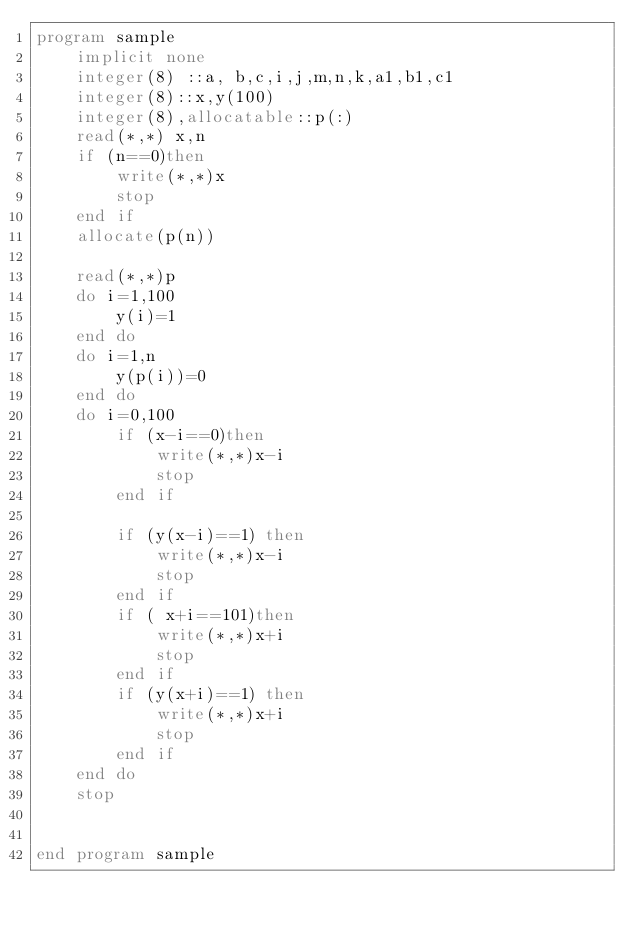<code> <loc_0><loc_0><loc_500><loc_500><_FORTRAN_>program sample
    implicit none
    integer(8) ::a, b,c,i,j,m,n,k,a1,b1,c1
    integer(8)::x,y(100)
    integer(8),allocatable::p(:)
    read(*,*) x,n
    if (n==0)then
        write(*,*)x
        stop
    end if
    allocate(p(n))

    read(*,*)p
    do i=1,100
        y(i)=1
    end do
    do i=1,n
        y(p(i))=0
    end do
    do i=0,100
        if (x-i==0)then
            write(*,*)x-i
            stop
        end if
        
        if (y(x-i)==1) then
            write(*,*)x-i
            stop
        end if
        if ( x+i==101)then
            write(*,*)x+i
            stop
        end if 
        if (y(x+i)==1) then
            write(*,*)x+i
            stop
        end if
    end do
    stop
    
    
end program sample
  

</code> 